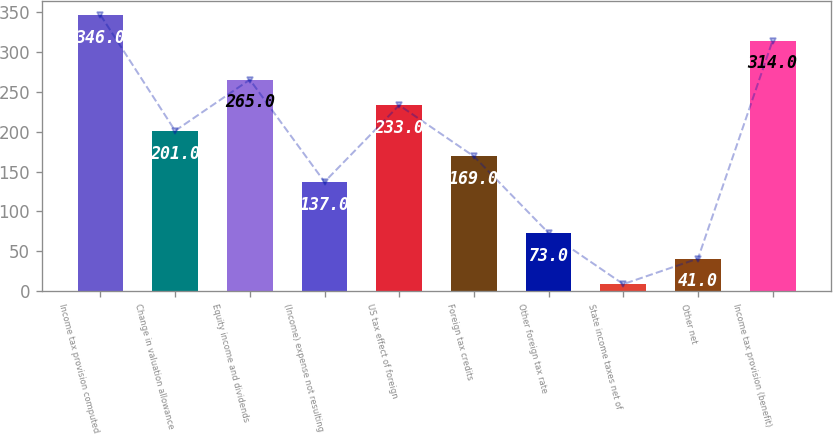Convert chart to OTSL. <chart><loc_0><loc_0><loc_500><loc_500><bar_chart><fcel>Income tax provision computed<fcel>Change in valuation allowance<fcel>Equity income and dividends<fcel>(Income) expense not resulting<fcel>US tax effect of foreign<fcel>Foreign tax credits<fcel>Other foreign tax rate<fcel>State income taxes net of<fcel>Other net<fcel>Income tax provision (benefit)<nl><fcel>346<fcel>201<fcel>265<fcel>137<fcel>233<fcel>169<fcel>73<fcel>9<fcel>41<fcel>314<nl></chart> 